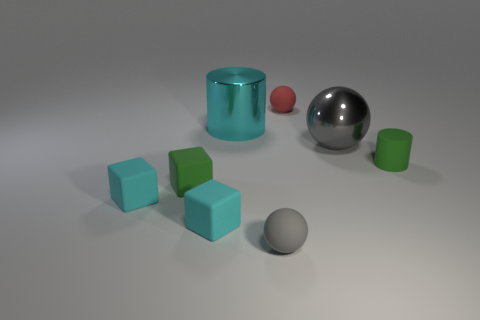What number of other things are the same shape as the gray shiny thing?
Your answer should be compact. 2. Do the tiny red rubber thing and the gray thing in front of the big gray ball have the same shape?
Give a very brief answer. Yes. There is a rubber cylinder; what number of cubes are behind it?
Ensure brevity in your answer.  0. Is there any other thing that has the same material as the tiny green block?
Make the answer very short. Yes. There is a big shiny object that is on the left side of the tiny red rubber ball; does it have the same shape as the large gray object?
Your answer should be compact. No. There is a cylinder to the left of the red rubber object; what is its color?
Your answer should be very brief. Cyan. There is a small red thing that is made of the same material as the tiny green cylinder; what shape is it?
Provide a short and direct response. Sphere. Are there any other things that have the same color as the big cylinder?
Your response must be concise. Yes. Are there more cyan matte objects that are behind the red matte object than large cyan objects that are in front of the tiny gray matte sphere?
Your answer should be compact. No. What number of gray shiny objects are the same size as the red matte sphere?
Your answer should be very brief. 0. 